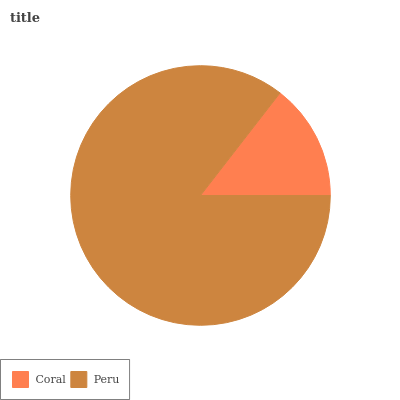Is Coral the minimum?
Answer yes or no. Yes. Is Peru the maximum?
Answer yes or no. Yes. Is Peru the minimum?
Answer yes or no. No. Is Peru greater than Coral?
Answer yes or no. Yes. Is Coral less than Peru?
Answer yes or no. Yes. Is Coral greater than Peru?
Answer yes or no. No. Is Peru less than Coral?
Answer yes or no. No. Is Peru the high median?
Answer yes or no. Yes. Is Coral the low median?
Answer yes or no. Yes. Is Coral the high median?
Answer yes or no. No. Is Peru the low median?
Answer yes or no. No. 